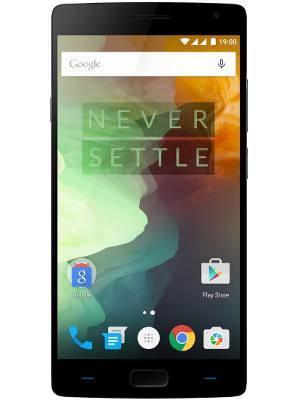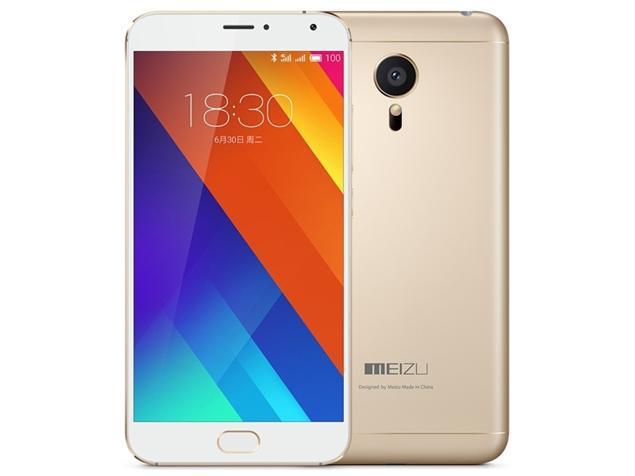The first image is the image on the left, the second image is the image on the right. Examine the images to the left and right. Is the description "The right image shows, in head-on view, a stylus to the right of a solid-colored device overlapped by the same shape with a screen on it." accurate? Answer yes or no. No. The first image is the image on the left, the second image is the image on the right. Assess this claim about the two images: "At least one image features the side profile of a phone.". Correct or not? Answer yes or no. No. 